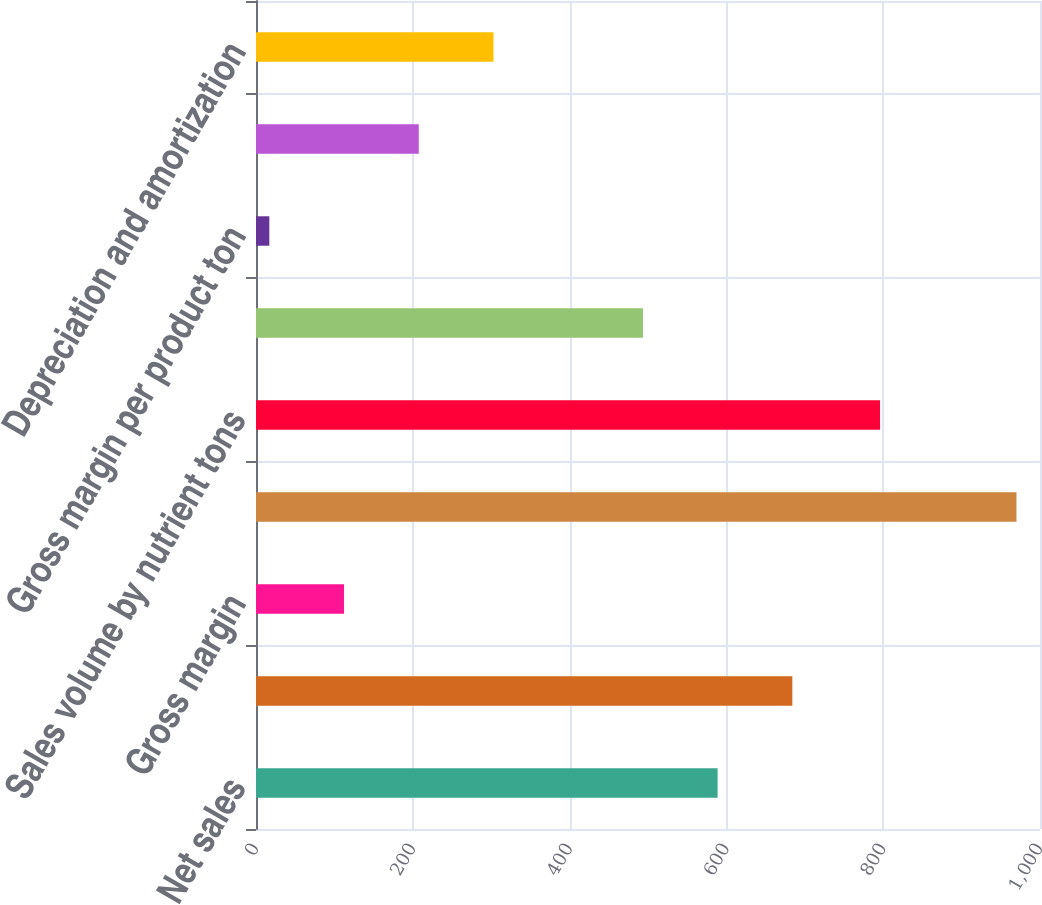Convert chart to OTSL. <chart><loc_0><loc_0><loc_500><loc_500><bar_chart><fcel>Net sales<fcel>Cost of sales<fcel>Gross margin<fcel>Sales volume by product tons<fcel>Sales volume by nutrient tons<fcel>Average selling price per<fcel>Gross margin per product ton<fcel>Gross margin per nutrient ton<fcel>Depreciation and amortization<nl><fcel>588.8<fcel>684.1<fcel>112.3<fcel>970<fcel>796<fcel>493.5<fcel>17<fcel>207.6<fcel>302.9<nl></chart> 